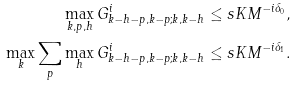Convert formula to latex. <formula><loc_0><loc_0><loc_500><loc_500>\max _ { k , p , h } G ^ { i } _ { k - h - p , k - p ; k , k - h } \leq s & K M ^ { - i \delta _ { 0 } } , \\ \max _ { k } \sum _ { p } \max _ { h } G ^ { i } _ { k - h - p , k - p ; k , k - h } \leq s & K M ^ { - i \delta _ { 1 } } .</formula> 